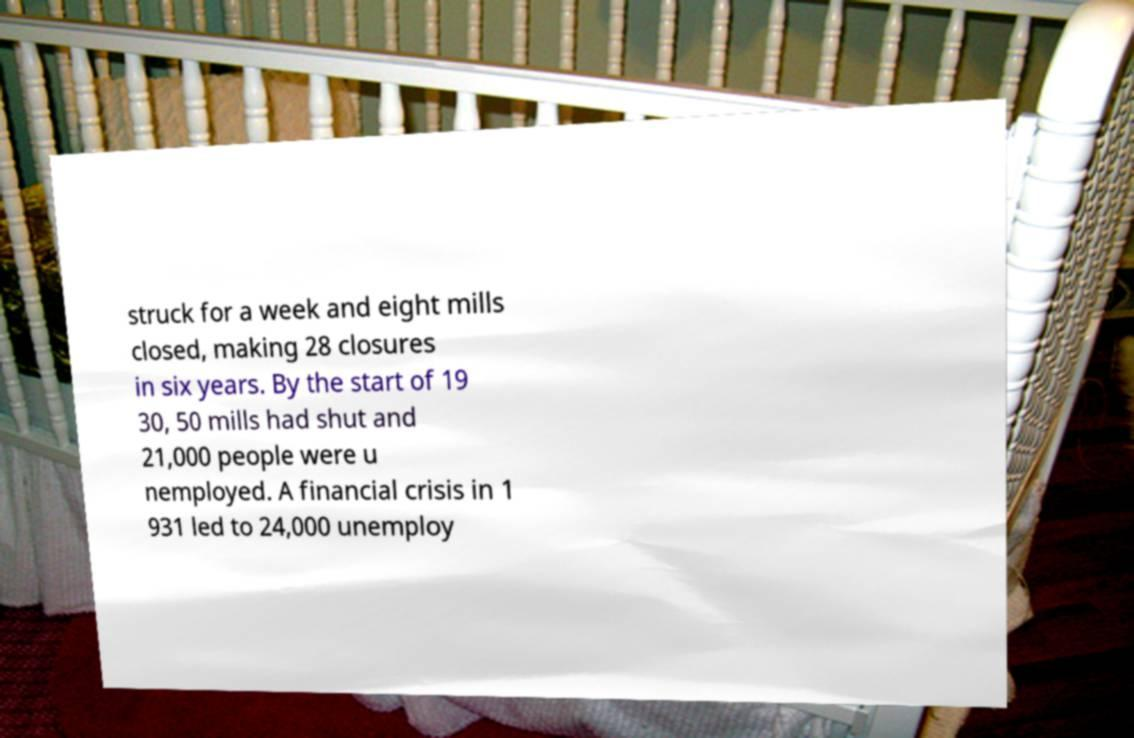What messages or text are displayed in this image? I need them in a readable, typed format. struck for a week and eight mills closed, making 28 closures in six years. By the start of 19 30, 50 mills had shut and 21,000 people were u nemployed. A financial crisis in 1 931 led to 24,000 unemploy 